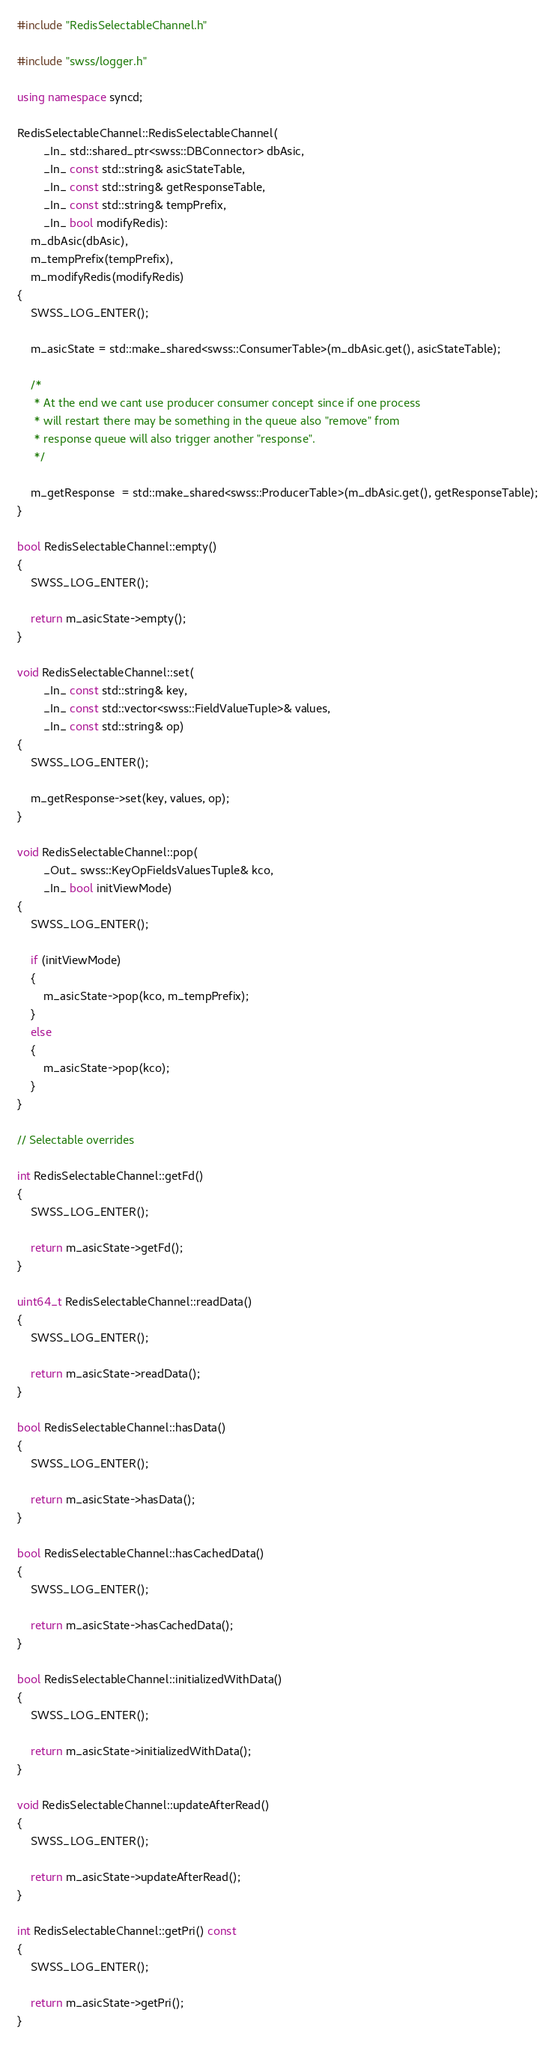<code> <loc_0><loc_0><loc_500><loc_500><_C++_>#include "RedisSelectableChannel.h"

#include "swss/logger.h"

using namespace syncd;

RedisSelectableChannel::RedisSelectableChannel(
        _In_ std::shared_ptr<swss::DBConnector> dbAsic,
        _In_ const std::string& asicStateTable,
        _In_ const std::string& getResponseTable,
        _In_ const std::string& tempPrefix,
        _In_ bool modifyRedis):
    m_dbAsic(dbAsic),
    m_tempPrefix(tempPrefix),
    m_modifyRedis(modifyRedis)
{
    SWSS_LOG_ENTER();

    m_asicState = std::make_shared<swss::ConsumerTable>(m_dbAsic.get(), asicStateTable);

    /*
     * At the end we cant use producer consumer concept since if one process
     * will restart there may be something in the queue also "remove" from
     * response queue will also trigger another "response".
     */

    m_getResponse  = std::make_shared<swss::ProducerTable>(m_dbAsic.get(), getResponseTable);
}

bool RedisSelectableChannel::empty() 
{
    SWSS_LOG_ENTER();

    return m_asicState->empty();
}

void RedisSelectableChannel::set(
        _In_ const std::string& key,
        _In_ const std::vector<swss::FieldValueTuple>& values,
        _In_ const std::string& op)
{
    SWSS_LOG_ENTER();

    m_getResponse->set(key, values, op);
}

void RedisSelectableChannel::pop(
        _Out_ swss::KeyOpFieldsValuesTuple& kco,
        _In_ bool initViewMode)
{
    SWSS_LOG_ENTER();

    if (initViewMode)
    {
        m_asicState->pop(kco, m_tempPrefix);
    }
    else
    {
        m_asicState->pop(kco);
    }
}

// Selectable overrides

int RedisSelectableChannel::getFd()
{
    SWSS_LOG_ENTER();

    return m_asicState->getFd();
}

uint64_t RedisSelectableChannel::readData()
{
    SWSS_LOG_ENTER();

    return m_asicState->readData();
}

bool RedisSelectableChannel::hasData()
{
    SWSS_LOG_ENTER();

    return m_asicState->hasData();
}

bool RedisSelectableChannel::hasCachedData()
{
    SWSS_LOG_ENTER();

    return m_asicState->hasCachedData();
}

bool RedisSelectableChannel::initializedWithData()
{
    SWSS_LOG_ENTER();

    return m_asicState->initializedWithData();
}

void RedisSelectableChannel::updateAfterRead()
{
    SWSS_LOG_ENTER();

    return m_asicState->updateAfterRead();
}

int RedisSelectableChannel::getPri() const
{
    SWSS_LOG_ENTER();

    return m_asicState->getPri();
}
</code> 